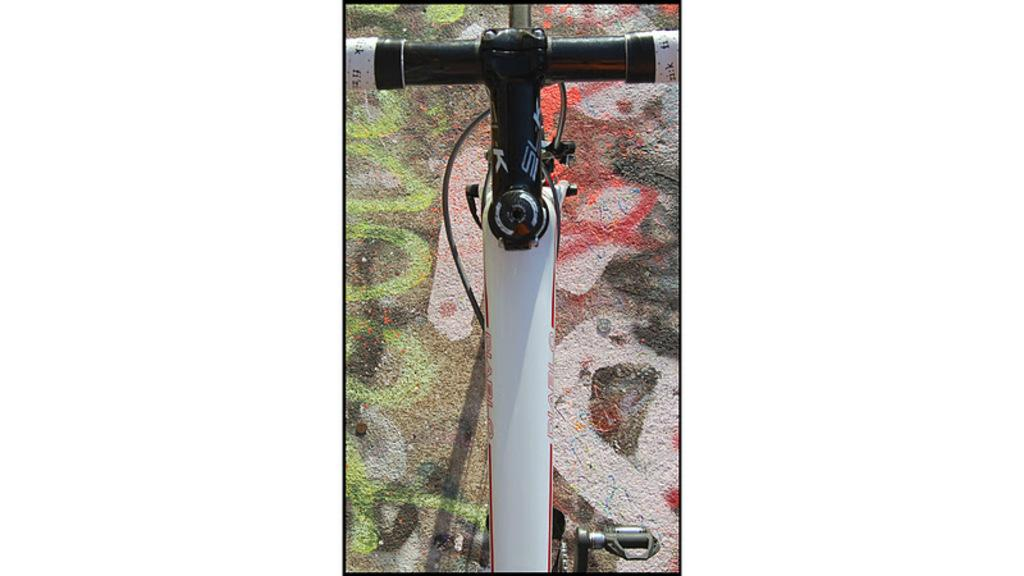What is the main object in the image? There is a bicycle in the image. Where is the bicycle located? The bicycle is on the floor. What is the volume of the voice coming from the bicycle in the image? There is no voice coming from the bicycle in the image, as it is an inanimate object. 